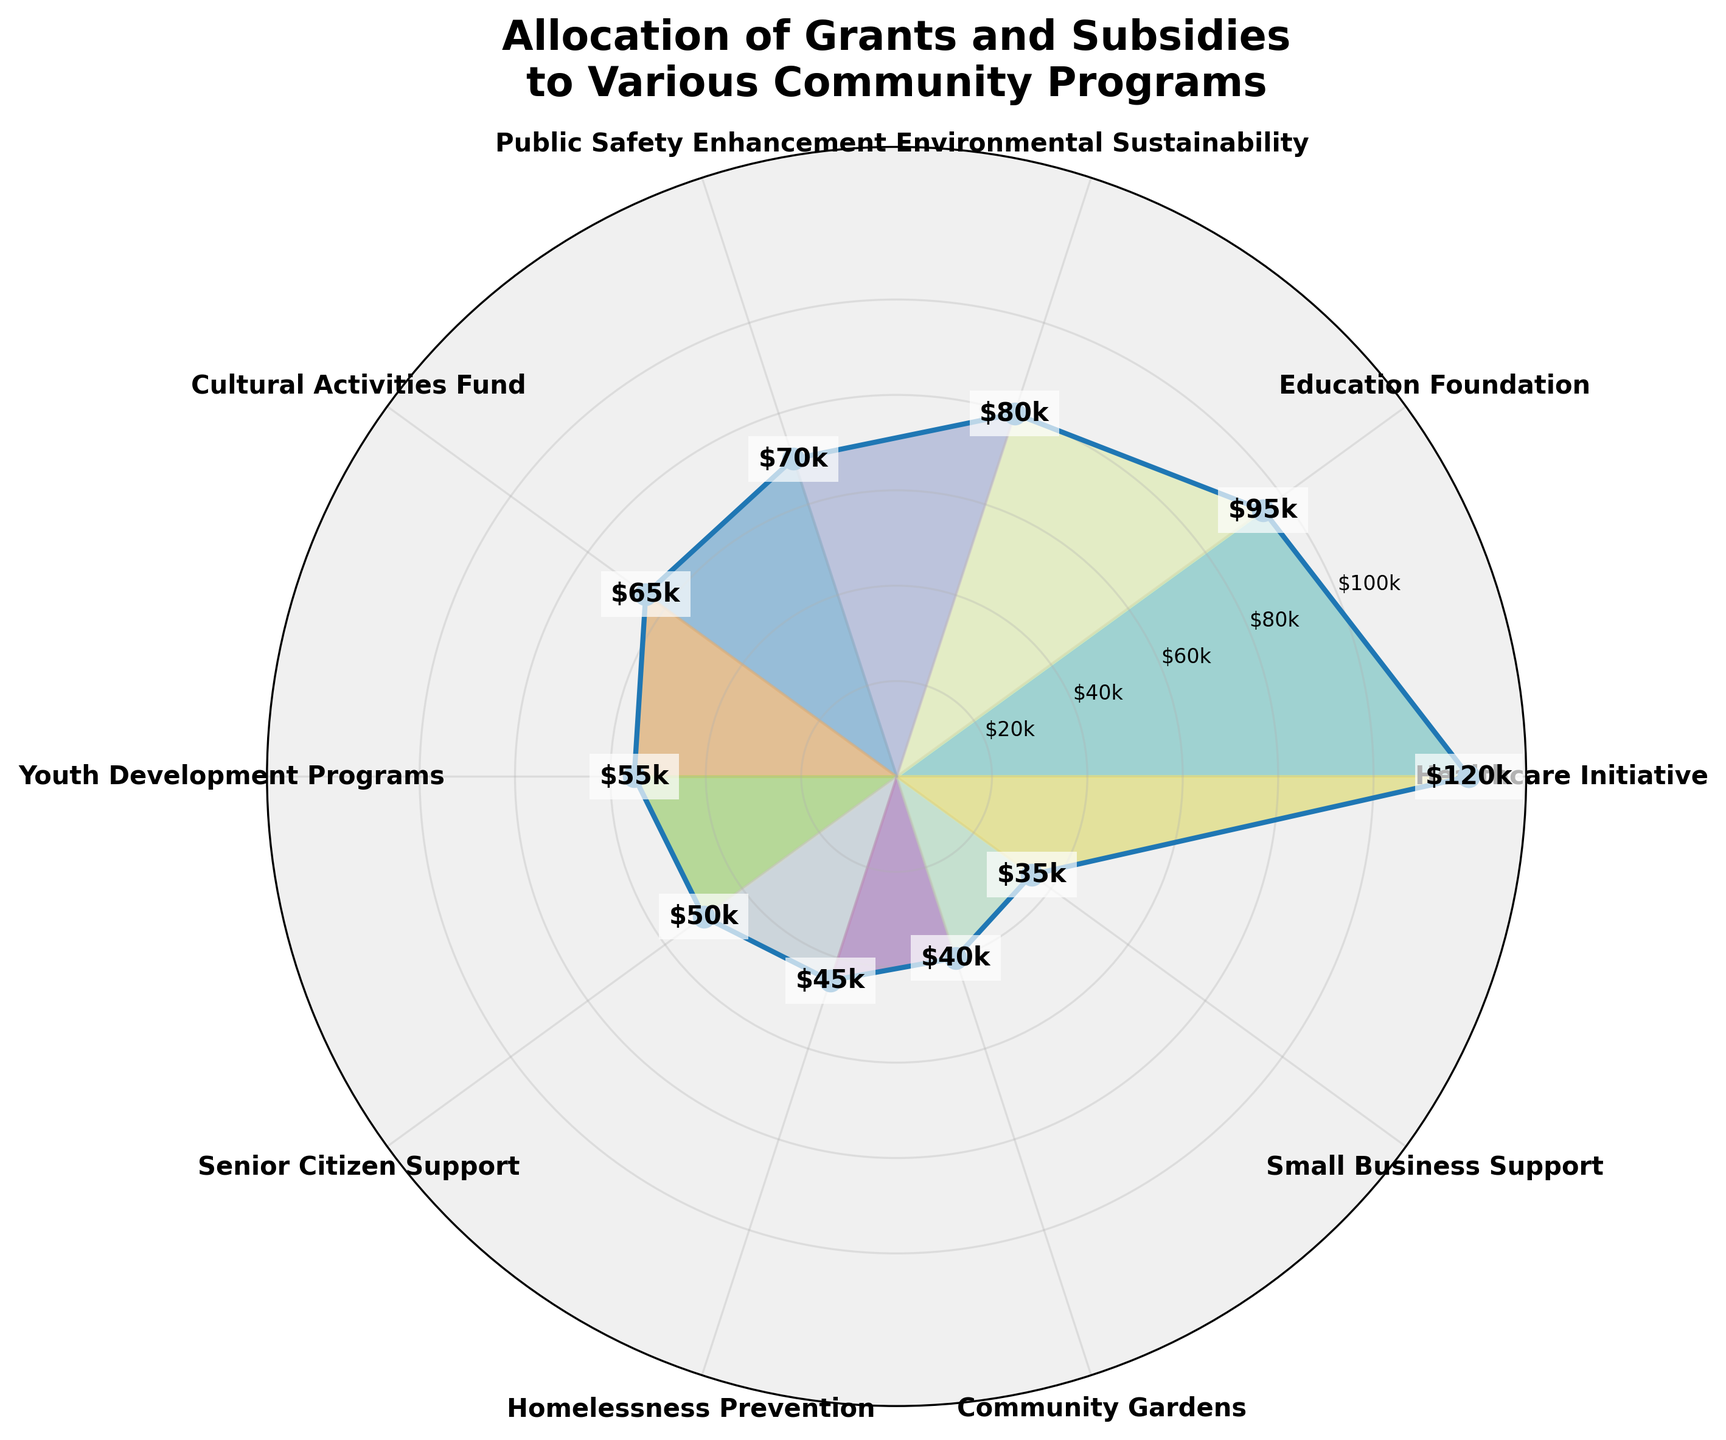What's the title of the figure? The title is located at the top of the figure and usually summarizes the content or purpose of the visualization. In this case, it shows the allocation of funds.
Answer: Allocation of Grants and Subsidies to Various Community Programs How many community programs are displayed in the chart? By counting the labels around the polar area chart, you can identify the number of different community programs.
Answer: 10 Which program has the highest allocation? Look for the program with the largest radial distance from the center of the chart. The one reaching the furthest is the highest allocated program.
Answer: Healthcare Initiative Which program has the lowest allocation? Check for the program with the smallest radial distance from the center. This indicates the lowest allocated program.
Answer: Small Business Support How much is allocated to the Community Gardens program? Find the label for Community Gardens and note the radial distance, which indicates the allocated amount.
Answer: $40k What is the total allocation for the top three programs? Identify the top three programs by their radial distances (Healthcare Initiative, Education Foundation, and Environmental Sustainability). Sum their allocations: $120k + $95k + $80k = $295k.
Answer: $295k How does the allocation for Youth Development Programs compare to Senior Citizen Support? Check the radial distances for both programs and compare them. Youth Development Programs has a higher allocation than Senior Citizen Support.
Answer: Youth Development Programs has a higher allocation What is the average allocation across all programs? Add all the allocations and divide by the number of programs: (120 + 95 + 80 + 70 + 65 + 55 + 50 + 45 + 40 + 35) / 10 = 65.5
Answer: $65.5k Which is greater: the sum of allocations for Cultural Activities Fund and Public Safety Enhancement or the total allocation for Healthcare Initiative? Calculate the sums: Cultural Activities Fund + Public Safety Enhancement = $65k + $70k = $135k. Compare it to Healthcare Initiative ($120k).
Answer: Cultural Activities Fund and Public Safety Enhancement combined What is the difference in allocation between Environmental Sustainability and Homelessness Prevention? Subtract the allocation of Homelessness Prevention from Environmental Sustainability: $80k - $45k = $35k.
Answer: $35k 